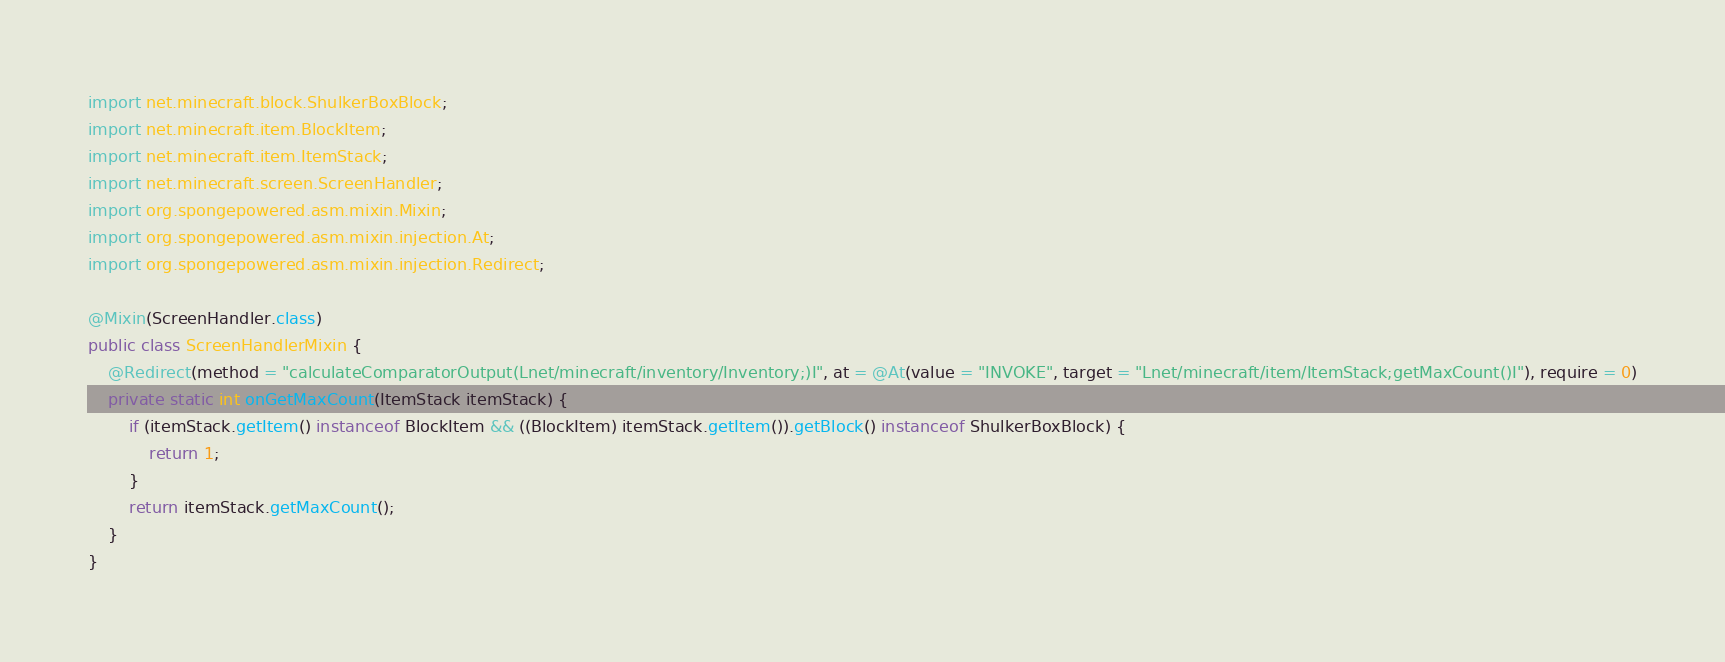<code> <loc_0><loc_0><loc_500><loc_500><_Java_>
import net.minecraft.block.ShulkerBoxBlock;
import net.minecraft.item.BlockItem;
import net.minecraft.item.ItemStack;
import net.minecraft.screen.ScreenHandler;
import org.spongepowered.asm.mixin.Mixin;
import org.spongepowered.asm.mixin.injection.At;
import org.spongepowered.asm.mixin.injection.Redirect;

@Mixin(ScreenHandler.class)
public class ScreenHandlerMixin {
	@Redirect(method = "calculateComparatorOutput(Lnet/minecraft/inventory/Inventory;)I", at = @At(value = "INVOKE", target = "Lnet/minecraft/item/ItemStack;getMaxCount()I"), require = 0)
	private static int onGetMaxCount(ItemStack itemStack) {
		if (itemStack.getItem() instanceof BlockItem && ((BlockItem) itemStack.getItem()).getBlock() instanceof ShulkerBoxBlock) {
			return 1;
		}
		return itemStack.getMaxCount();
	}
}
</code> 